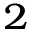Convert formula to latex. <formula><loc_0><loc_0><loc_500><loc_500>{ ^ { 2 } }</formula> 